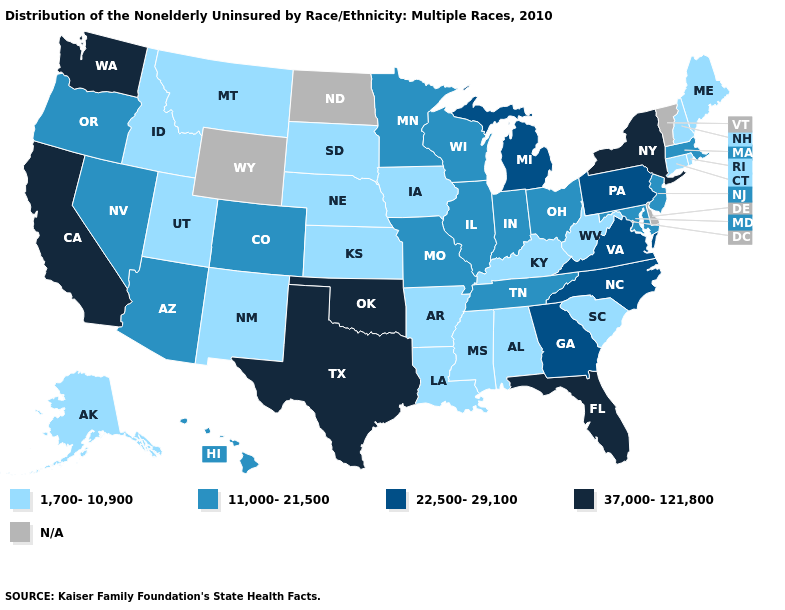Among the states that border New Mexico , does Utah have the highest value?
Concise answer only. No. Which states have the lowest value in the USA?
Answer briefly. Alabama, Alaska, Arkansas, Connecticut, Idaho, Iowa, Kansas, Kentucky, Louisiana, Maine, Mississippi, Montana, Nebraska, New Hampshire, New Mexico, Rhode Island, South Carolina, South Dakota, Utah, West Virginia. What is the value of Virginia?
Short answer required. 22,500-29,100. What is the value of Mississippi?
Write a very short answer. 1,700-10,900. Name the states that have a value in the range 11,000-21,500?
Be succinct. Arizona, Colorado, Hawaii, Illinois, Indiana, Maryland, Massachusetts, Minnesota, Missouri, Nevada, New Jersey, Ohio, Oregon, Tennessee, Wisconsin. What is the value of Nebraska?
Write a very short answer. 1,700-10,900. Name the states that have a value in the range 22,500-29,100?
Be succinct. Georgia, Michigan, North Carolina, Pennsylvania, Virginia. What is the value of Idaho?
Short answer required. 1,700-10,900. What is the highest value in the USA?
Write a very short answer. 37,000-121,800. What is the value of Virginia?
Give a very brief answer. 22,500-29,100. What is the value of Georgia?
Concise answer only. 22,500-29,100. Name the states that have a value in the range 37,000-121,800?
Write a very short answer. California, Florida, New York, Oklahoma, Texas, Washington. What is the lowest value in states that border Maryland?
Give a very brief answer. 1,700-10,900. Name the states that have a value in the range 11,000-21,500?
Write a very short answer. Arizona, Colorado, Hawaii, Illinois, Indiana, Maryland, Massachusetts, Minnesota, Missouri, Nevada, New Jersey, Ohio, Oregon, Tennessee, Wisconsin. 